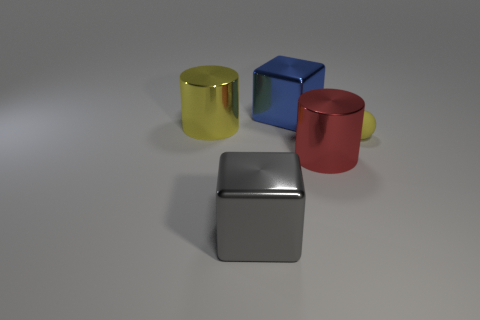Subtract all blue cylinders. How many cyan balls are left? 0 Subtract 1 cylinders. How many cylinders are left? 1 Subtract all yellow cylinders. Subtract all red balls. How many cylinders are left? 1 Subtract all large yellow cylinders. Subtract all yellow rubber balls. How many objects are left? 3 Add 3 tiny rubber spheres. How many tiny rubber spheres are left? 4 Add 3 small brown metallic objects. How many small brown metallic objects exist? 3 Add 1 large blue objects. How many objects exist? 6 Subtract 0 brown balls. How many objects are left? 5 Subtract all cylinders. How many objects are left? 3 